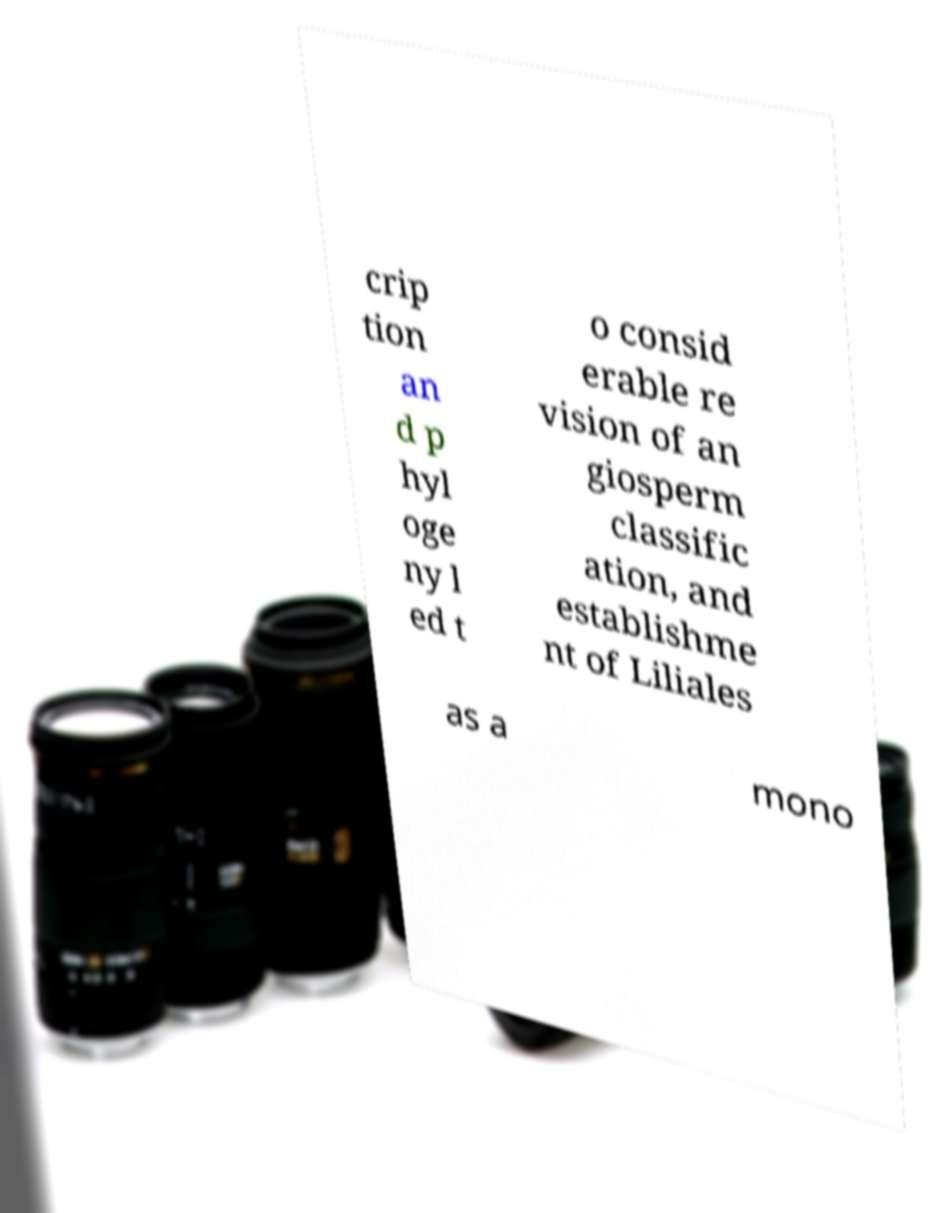Could you assist in decoding the text presented in this image and type it out clearly? crip tion an d p hyl oge ny l ed t o consid erable re vision of an giosperm classific ation, and establishme nt of Liliales as a mono 